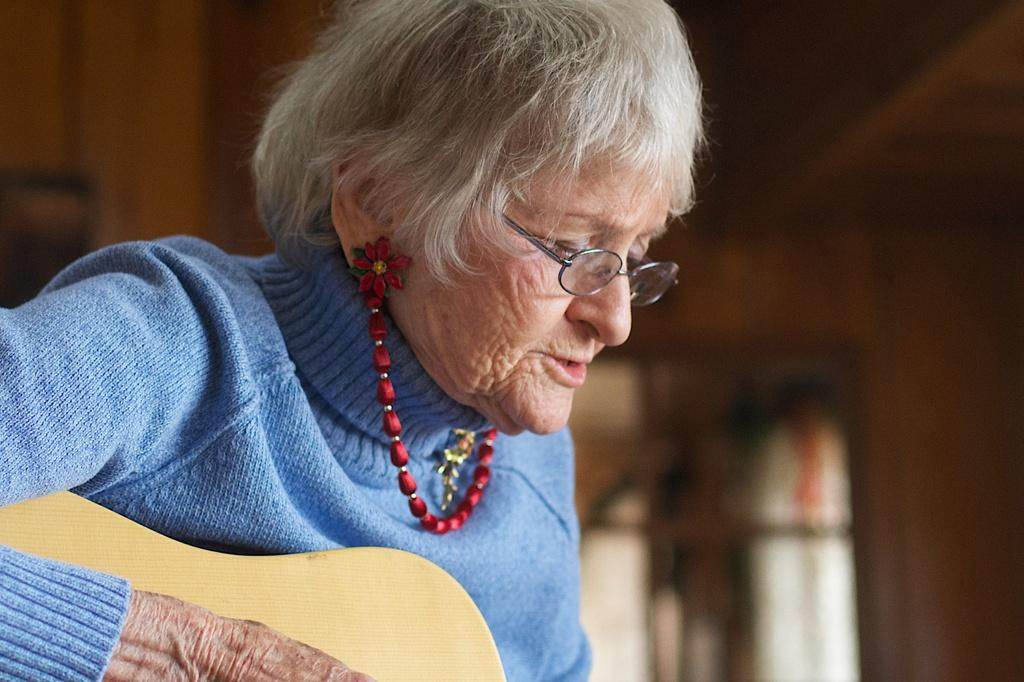Who is the main subject in the image? There is a woman in the image. What is the woman wearing? The woman is wearing a blue dress and a red chain. What is the woman holding? The woman is holding a guitar. What is the woman doing with the guitar? The woman is playing the guitar. What accessory is the woman wearing on her face? The woman is wearing specs. What type of rhythm can be heard coming from the woman's crush in the image? There is no mention of a crush or any sound in the image, so it's not possible to determine the type of rhythm. 